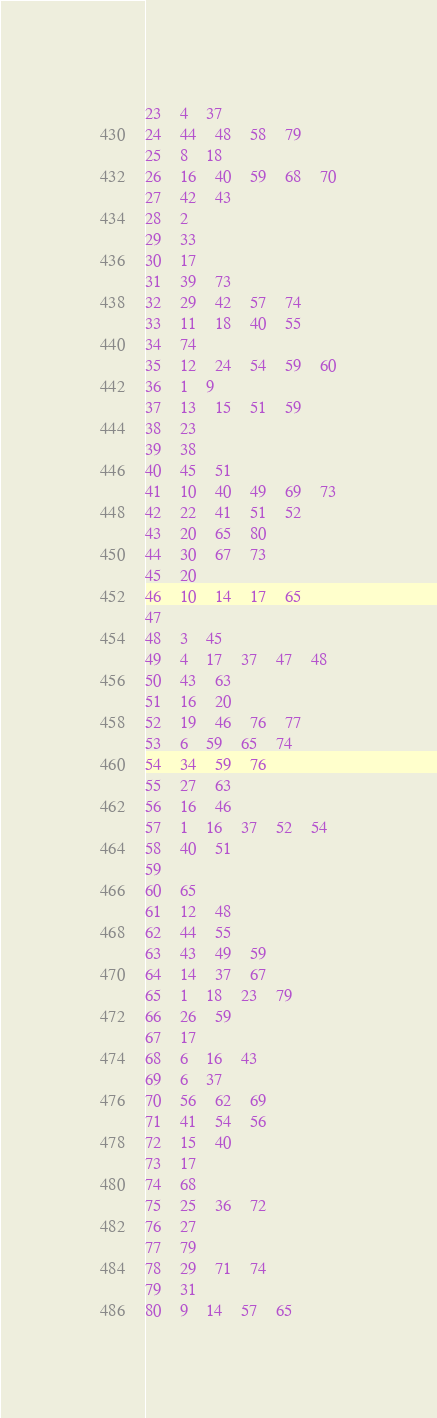Convert code to text. <code><loc_0><loc_0><loc_500><loc_500><_Perl_>23	4	37
24	44	48	58	79
25	8	18
26	16	40	59	68	70
27	42	43
28	2
29	33
30	17
31	39	73
32	29	42	57	74
33	11	18	40	55
34	74
35	12	24	54	59	60
36	1	9
37	13	15	51	59
38	23
39	38
40	45	51
41	10	40	49	69	73
42	22	41	51	52
43	20	65	80
44	30	67	73
45	20
46	10	14	17	65
47
48	3	45
49	4	17	37	47	48
50	43	63
51	16	20
52	19	46	76	77
53	6	59	65	74
54	34	59	76
55	27	63
56	16	46
57	1	16	37	52	54
58	40	51
59
60	65
61	12	48
62	44	55
63	43	49	59
64	14	37	67
65	1	18	23	79
66	26	59
67	17
68	6	16	43
69	6	37
70	56	62	69
71	41	54	56
72	15	40
73	17
74	68
75	25	36	72
76	27
77	79
78	29	71	74
79	31
80	9	14	57	65</code> 